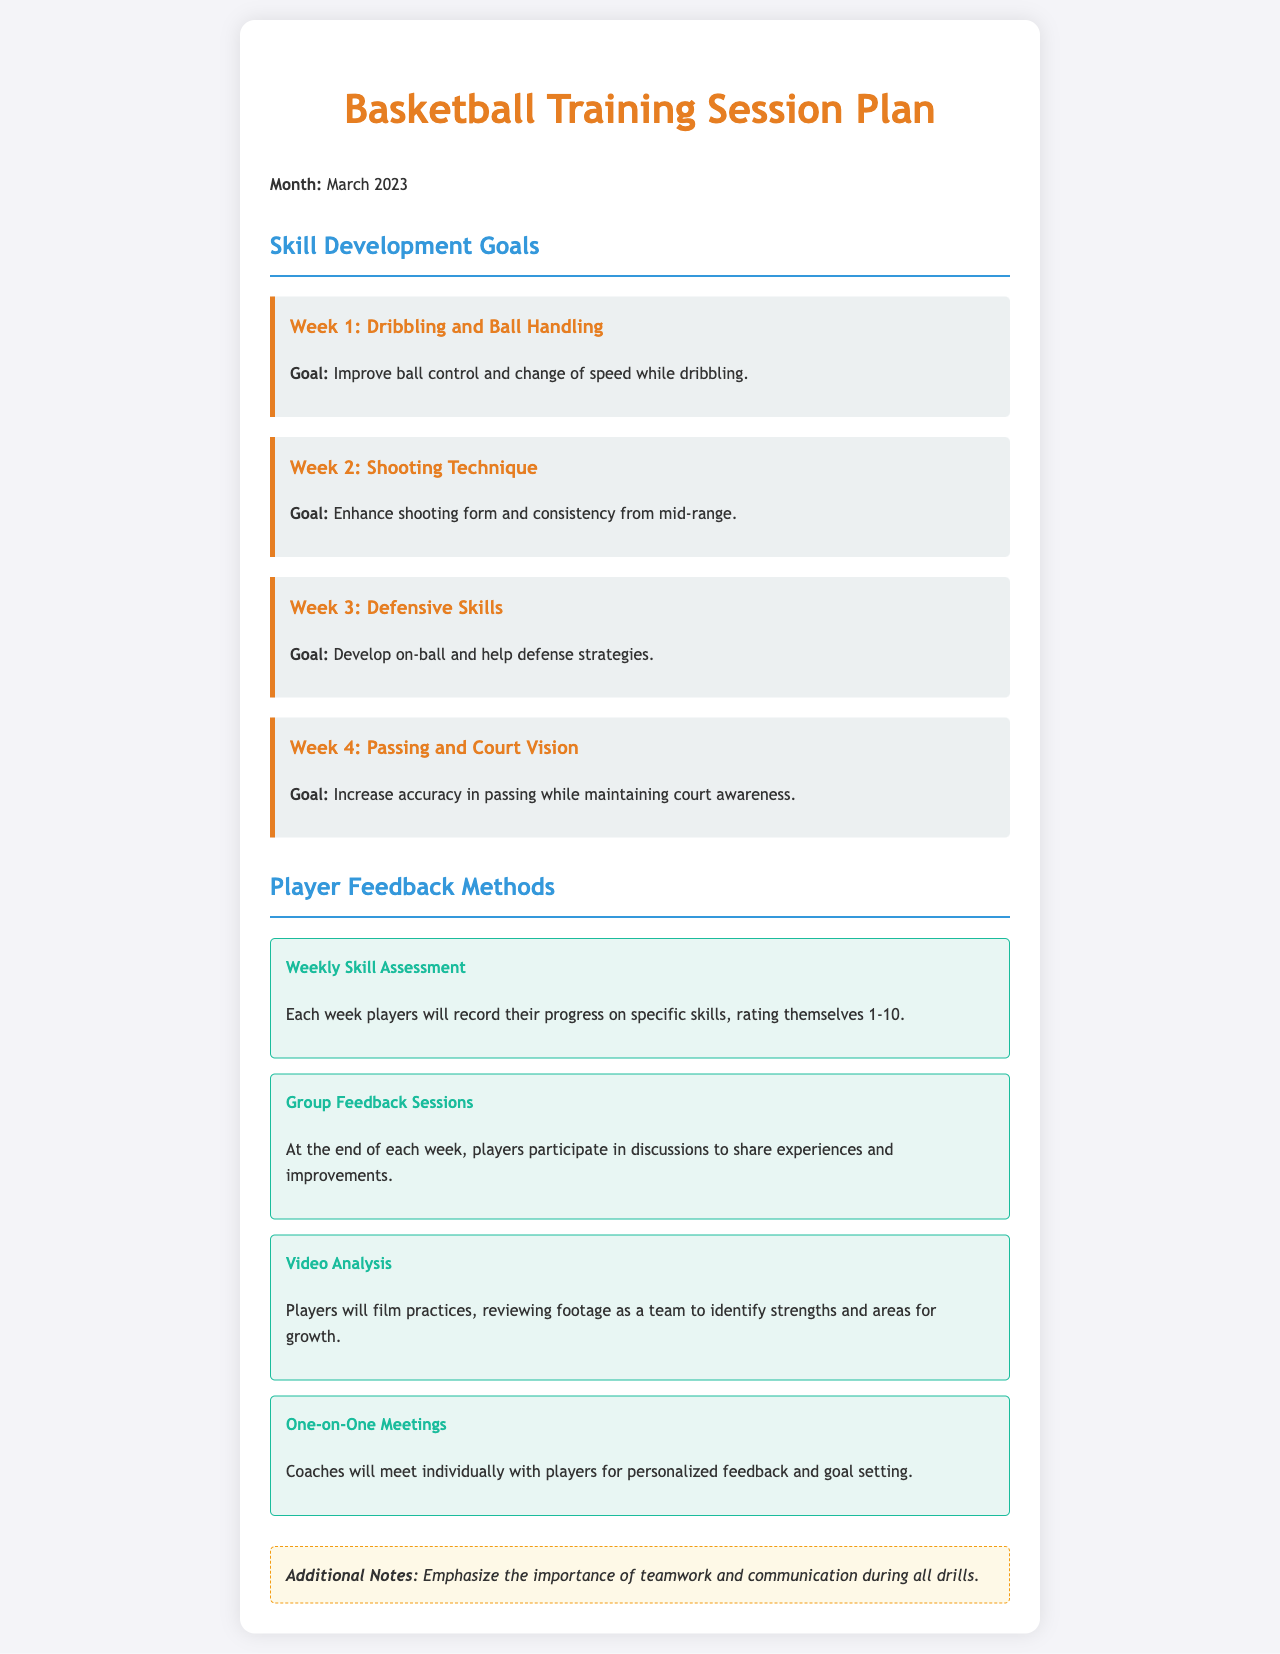what is the title of the document? The title is displayed prominently at the top of the document, indicating its purpose and content.
Answer: Basketball Training Session Plan - March 2023 how many weeks of skill development goals are detailed in the document? The document includes a specific section that outlines skill development goals for each week, which can be counted.
Answer: 4 what is the goal for week 2? The goal for week 2 is explicitly mentioned in the text under that week's heading, detailing the focus for the sessions.
Answer: Enhance shooting form and consistency from mid-range what method is used for weekly skill assessment? The document specifies a formal approach for assessing skills that players will follow each week.
Answer: Weekly Skill Assessment how will players provide feedback at the end of each week? The document describes a mechanism for players to share experiences and improvements, indicating group interaction.
Answer: Group Feedback Sessions which week focuses on defensive skills? Each week has a designated focus, and this particular week's skill area is highlighted in the document.
Answer: Week 3 how will video analysis contribute to player development? The document highlights the use of video footage for collective review and improvement, providing insight into player development.
Answer: Identify strengths and areas for growth what additional emphasis is noted in the document? The document concludes with supplementary guidance that reinforces key concepts critical to the training approach.
Answer: Importance of teamwork and communication 